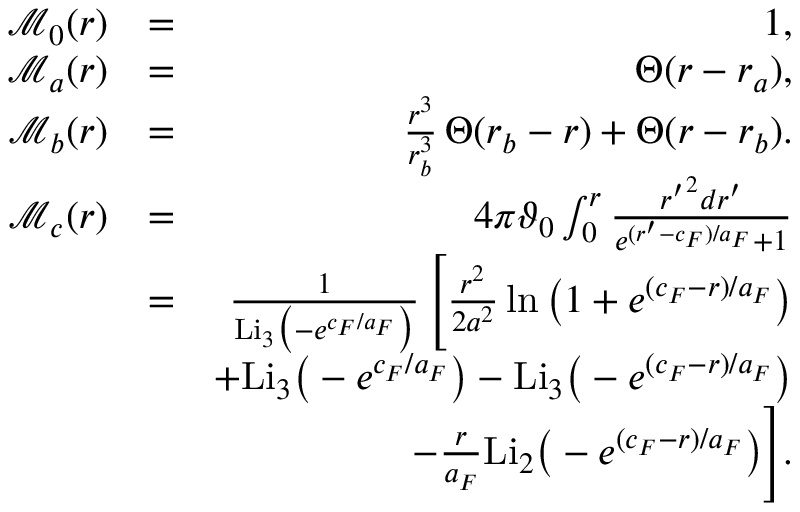Convert formula to latex. <formula><loc_0><loc_0><loc_500><loc_500>\begin{array} { r l r } { \mathcal { M } _ { 0 } ( r ) } & { = } & { 1 , } \\ { \mathcal { M } _ { a } ( r ) } & { = } & { \Theta ( r - r _ { a } ) , } \\ { \mathcal { M } _ { b } ( r ) } & { = } & { \frac { r ^ { 3 } } { r _ { b } ^ { 3 } } \, \Theta ( r _ { b } - r ) + \Theta ( r - r _ { b } ) . } \\ { \mathcal { M } _ { c } ( r ) } & { = } & { 4 \pi \vartheta _ { 0 } \int _ { 0 } ^ { r } \frac { { r ^ { \prime } } ^ { 2 } d r ^ { \prime } } { e ^ { ( r ^ { \prime } - c _ { F } ) / a _ { F } } + 1 } } \\ & { = } & { \frac { 1 } { L i _ { 3 } \left ( - e ^ { c _ { F } / a _ { F } } \right ) } \, \left [ \frac { r ^ { 2 } } { 2 a ^ { 2 } } \ln \left ( 1 + e ^ { ( c _ { F } - r ) / a _ { F } } \right ) } \\ & { + L i _ { 3 } \left ( - e ^ { c _ { F } / a _ { F } } \right ) - L i _ { 3 } \left ( - e ^ { ( c _ { F } - r ) / a _ { F } } \right ) } \\ & { - \frac { r } { a _ { F } } L i _ { 2 } \left ( - e ^ { ( c _ { F } - r ) / a _ { F } } \right ) \right ] . } \end{array}</formula> 